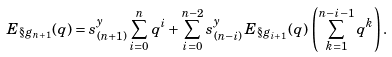Convert formula to latex. <formula><loc_0><loc_0><loc_500><loc_500>E _ { \S g _ { n + 1 } } ( q ) = s ^ { y } _ { ( n + 1 ) } \sum _ { i = 0 } ^ { n } q ^ { i } + \sum _ { i = 0 } ^ { n - 2 } s ^ { y } _ { ( n - i ) } \, E _ { \S g _ { i + 1 } } ( q ) \, \left ( \sum _ { k = 1 } ^ { n - i - 1 } q ^ { k } \right ) .</formula> 